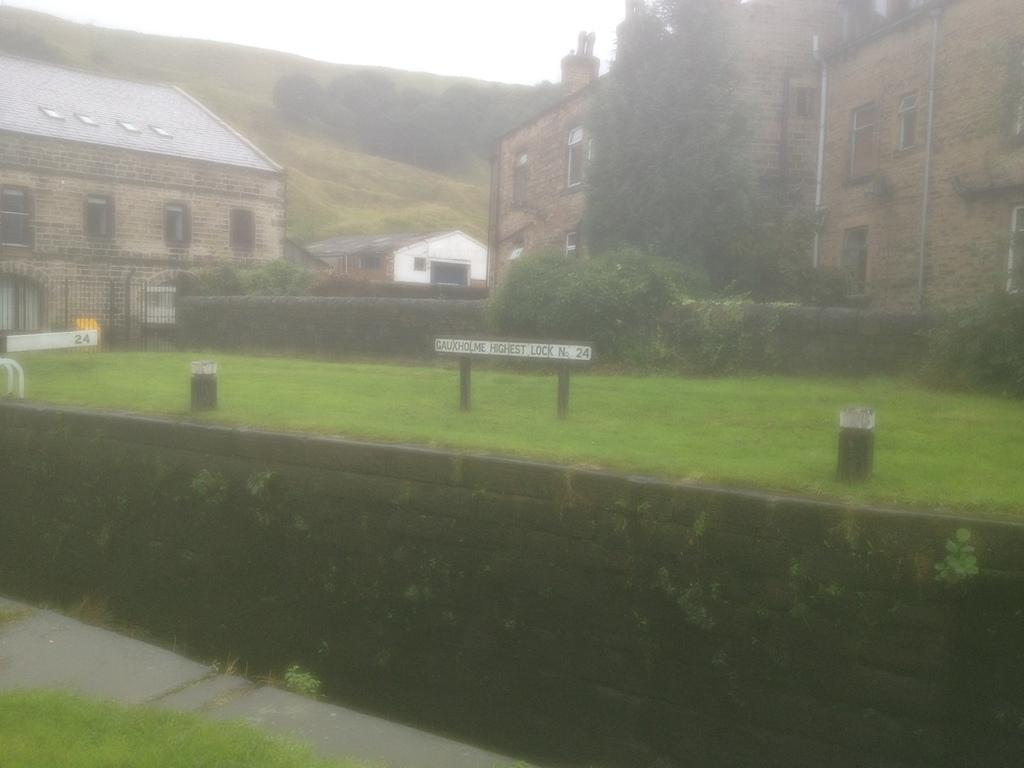What type of structures can be seen in the image? There are buildings in the image. What type of vegetation is visible in the image? There is grass, trees, and plants visible in the image. What else can be found on the ground in the image? There are other objects on the ground in the image. What is visible in the background of the image? There are trees and the sky visible in the background of the image. What flavor of bear can be seen in the image? There are no bears present in the image. What type of flag is visible in the image in the image? There is no flag visible in the image. 